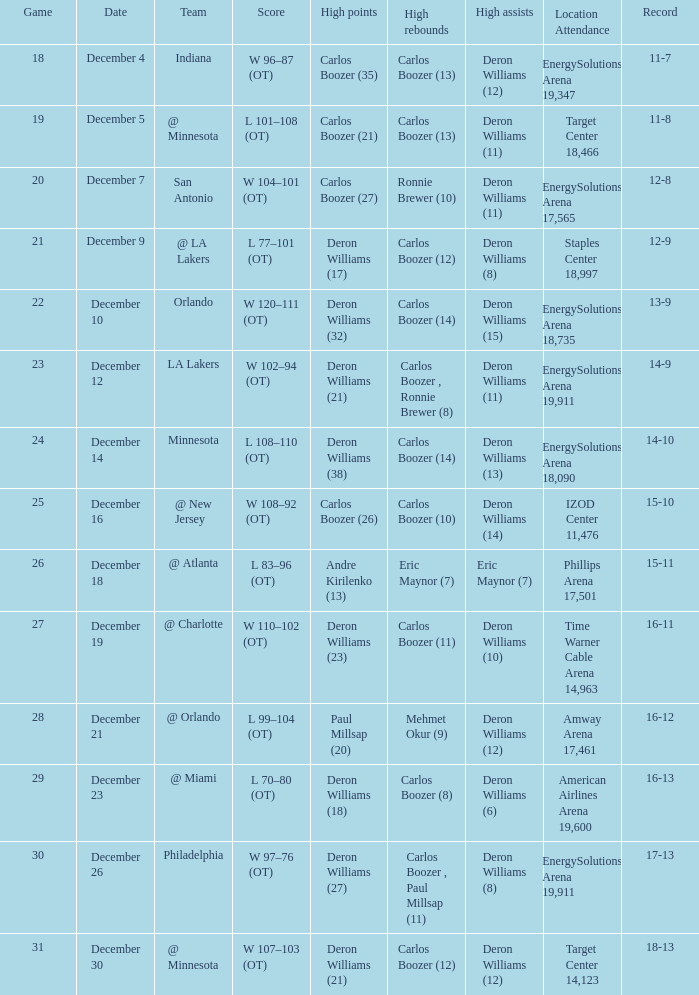What is the count of distinct high rebound outcomes for game number 26? 1.0. Parse the full table. {'header': ['Game', 'Date', 'Team', 'Score', 'High points', 'High rebounds', 'High assists', 'Location Attendance', 'Record'], 'rows': [['18', 'December 4', 'Indiana', 'W 96–87 (OT)', 'Carlos Boozer (35)', 'Carlos Boozer (13)', 'Deron Williams (12)', 'EnergySolutions Arena 19,347', '11-7'], ['19', 'December 5', '@ Minnesota', 'L 101–108 (OT)', 'Carlos Boozer (21)', 'Carlos Boozer (13)', 'Deron Williams (11)', 'Target Center 18,466', '11-8'], ['20', 'December 7', 'San Antonio', 'W 104–101 (OT)', 'Carlos Boozer (27)', 'Ronnie Brewer (10)', 'Deron Williams (11)', 'EnergySolutions Arena 17,565', '12-8'], ['21', 'December 9', '@ LA Lakers', 'L 77–101 (OT)', 'Deron Williams (17)', 'Carlos Boozer (12)', 'Deron Williams (8)', 'Staples Center 18,997', '12-9'], ['22', 'December 10', 'Orlando', 'W 120–111 (OT)', 'Deron Williams (32)', 'Carlos Boozer (14)', 'Deron Williams (15)', 'EnergySolutions Arena 18,735', '13-9'], ['23', 'December 12', 'LA Lakers', 'W 102–94 (OT)', 'Deron Williams (21)', 'Carlos Boozer , Ronnie Brewer (8)', 'Deron Williams (11)', 'EnergySolutions Arena 19,911', '14-9'], ['24', 'December 14', 'Minnesota', 'L 108–110 (OT)', 'Deron Williams (38)', 'Carlos Boozer (14)', 'Deron Williams (13)', 'EnergySolutions Arena 18,090', '14-10'], ['25', 'December 16', '@ New Jersey', 'W 108–92 (OT)', 'Carlos Boozer (26)', 'Carlos Boozer (10)', 'Deron Williams (14)', 'IZOD Center 11,476', '15-10'], ['26', 'December 18', '@ Atlanta', 'L 83–96 (OT)', 'Andre Kirilenko (13)', 'Eric Maynor (7)', 'Eric Maynor (7)', 'Phillips Arena 17,501', '15-11'], ['27', 'December 19', '@ Charlotte', 'W 110–102 (OT)', 'Deron Williams (23)', 'Carlos Boozer (11)', 'Deron Williams (10)', 'Time Warner Cable Arena 14,963', '16-11'], ['28', 'December 21', '@ Orlando', 'L 99–104 (OT)', 'Paul Millsap (20)', 'Mehmet Okur (9)', 'Deron Williams (12)', 'Amway Arena 17,461', '16-12'], ['29', 'December 23', '@ Miami', 'L 70–80 (OT)', 'Deron Williams (18)', 'Carlos Boozer (8)', 'Deron Williams (6)', 'American Airlines Arena 19,600', '16-13'], ['30', 'December 26', 'Philadelphia', 'W 97–76 (OT)', 'Deron Williams (27)', 'Carlos Boozer , Paul Millsap (11)', 'Deron Williams (8)', 'EnergySolutions Arena 19,911', '17-13'], ['31', 'December 30', '@ Minnesota', 'W 107–103 (OT)', 'Deron Williams (21)', 'Carlos Boozer (12)', 'Deron Williams (12)', 'Target Center 14,123', '18-13']]} 